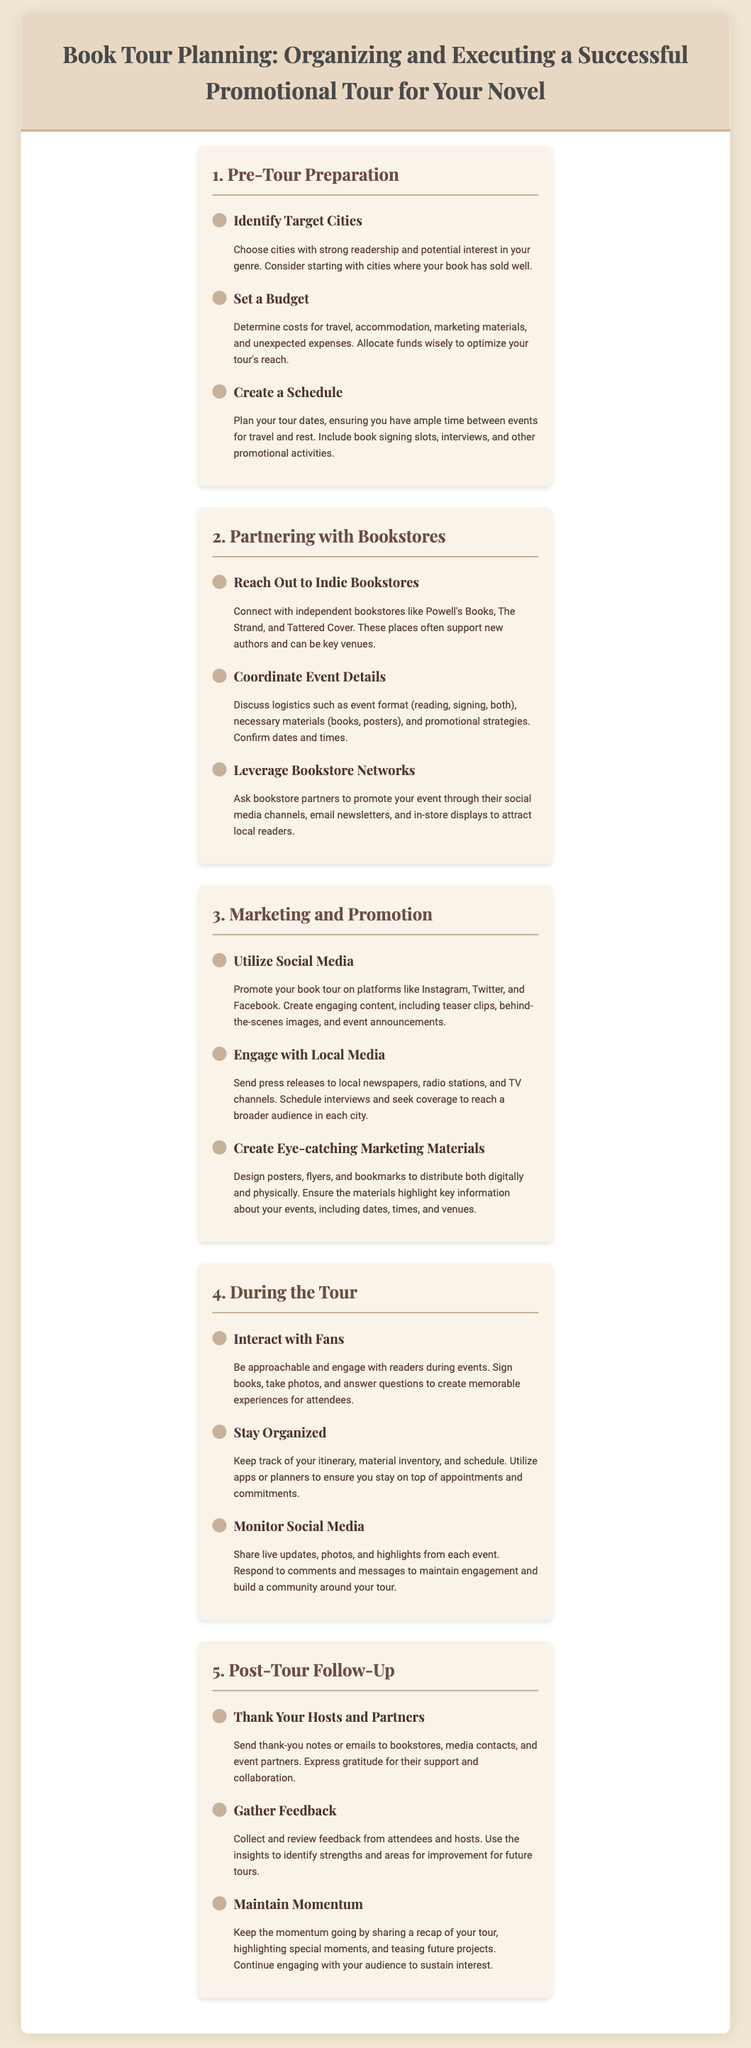What is the title of the infographic? The title of the infographic is prominently displayed at the top of the document.
Answer: Book Tour Planning: Organizing and Executing a Successful Promotional Tour for Your Novel How many main sections are in the infographic? The infographic is organized into five distinct sections, each covering a different aspect of book tour planning.
Answer: 5 What is one method to promote your book tour mentioned in the document? The document provides several marketing strategies, including utilizing social media.
Answer: Utilize Social Media What should you do after the tour to maintain momentum? The infographic suggests following up with your audience to sustain interest after the tour ends.
Answer: Maintain Momentum Which action is recommended when reaching out to bookstores? The document specifies connecting with independent bookstores as a crucial step in partnering for events.
Answer: Reach Out to Indie Bookstores What is a key consideration when setting a budget for the tour? The infographic mentions determining costs for travel, accommodation, marketing materials, and unexpected expenses.
Answer: Unexpected expenses What should you do during the tour to stay organized? The document advises keeping track of your itinerary, material inventory, and schedule to ensure everything runs smoothly.
Answer: Stay Organized How should you express gratitude to event partners post-tour? The infographic highlights sending thank-you notes or emails as a way to show appreciation for support.
Answer: Thank-You Notes What format should the events with bookstores include? The document suggests discussing logistics, including event formats such as readings or signings.
Answer: Reading, signing, both 